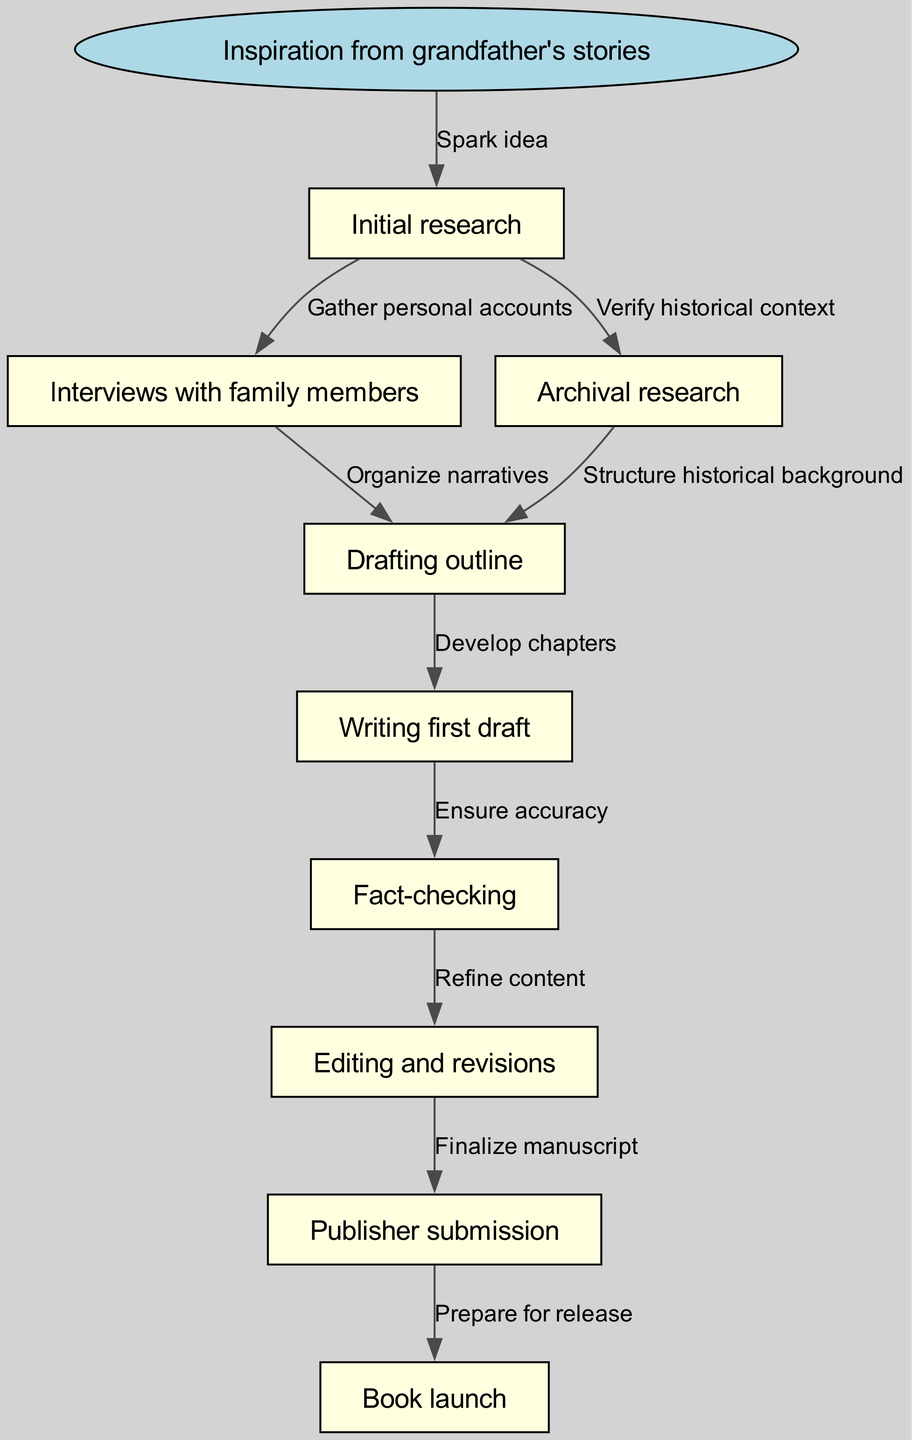What is the starting point of the process? The starting point is clearly labeled in the diagram and is represented by the node "Inspiration from grandfather's stories." This is the first step in the flowchart.
Answer: Inspiration from grandfather's stories How many nodes are present in the diagram? Counting all the nodes listed in the diagram, including the starting point and subsequent steps, there are a total of ten nodes.
Answer: 10 What label describes the transition from "Initial research" to "Interviews with family members"? The edge between these two nodes is labeled "Gather personal accounts." This label indicates the nature of the transition from researching to gathering personal accounts.
Answer: Gather personal accounts Which step comes directly after "Drafting outline"? The flowchart indicates that the step that comes directly after "Drafting outline" is "Writing first draft." This can be followed through the directed edges connecting the nodes.
Answer: Writing first draft What is the final step in the process illustrated in the diagram? The final step of the flowchart is labeled "Book launch," indicating the conclusion of the research and writing process.
Answer: Book launch Which research method is used to verify historical context? The edge branching from "Initial research" to "Archival research" is labeled "Verify historical context," indicating that archival research serves this purpose in the process.
Answer: Archival research What follows "Fact-checking" in the sequence of steps? The diagram clearly indicates that "Editing and revisions" follows "Fact-checking." This sequence shows the progression after ensuring the accuracy of the content.
Answer: Editing and revisions How does "Interviews with family members" connect with the drafting processes? The node "Interviews with family members" connects to "Drafting outline," and the edge indicating this relationship is labeled "Organize narratives," showing how personal stories are structured into the outline.
Answer: Organize narratives What action is described by the edge from "Publisher submission" to "Book launch"? The edge connecting these nodes is labeled "Prepare for release," highlighting the preparatory actions necessary before the book is officially launched.
Answer: Prepare for release 